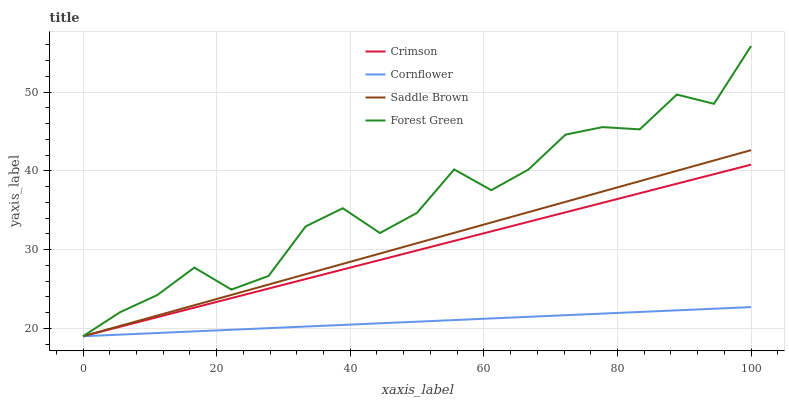Does Cornflower have the minimum area under the curve?
Answer yes or no. Yes. Does Forest Green have the maximum area under the curve?
Answer yes or no. Yes. Does Forest Green have the minimum area under the curve?
Answer yes or no. No. Does Cornflower have the maximum area under the curve?
Answer yes or no. No. Is Saddle Brown the smoothest?
Answer yes or no. Yes. Is Forest Green the roughest?
Answer yes or no. Yes. Is Cornflower the smoothest?
Answer yes or no. No. Is Cornflower the roughest?
Answer yes or no. No. Does Crimson have the lowest value?
Answer yes or no. Yes. Does Forest Green have the highest value?
Answer yes or no. Yes. Does Cornflower have the highest value?
Answer yes or no. No. Does Forest Green intersect Cornflower?
Answer yes or no. Yes. Is Forest Green less than Cornflower?
Answer yes or no. No. Is Forest Green greater than Cornflower?
Answer yes or no. No. 